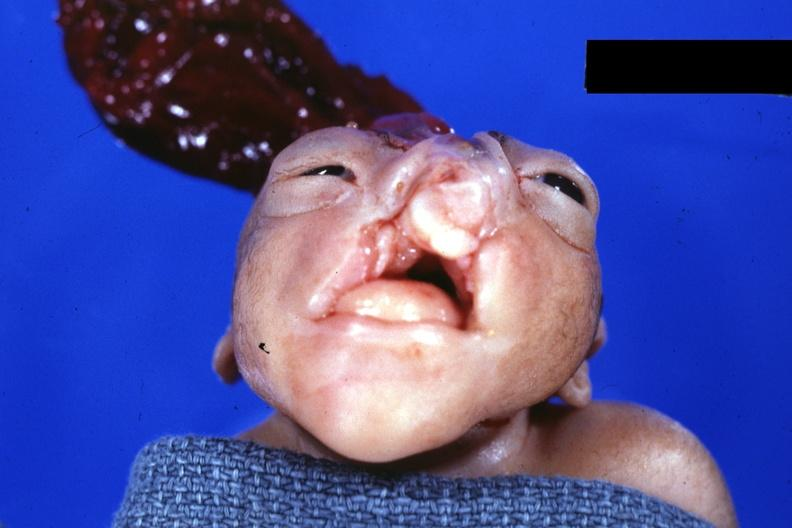what does this image show?
Answer the question using a single word or phrase. Frontal view close-up 